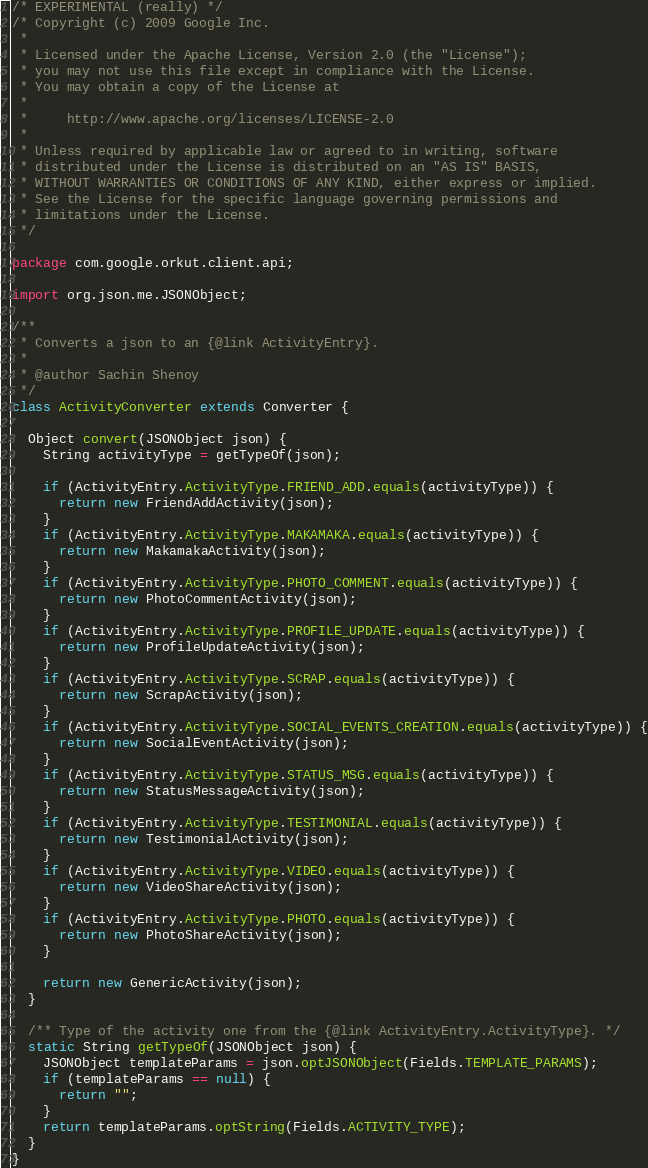Convert code to text. <code><loc_0><loc_0><loc_500><loc_500><_Java_>/* EXPERIMENTAL (really) */
/* Copyright (c) 2009 Google Inc.
 *
 * Licensed under the Apache License, Version 2.0 (the "License");
 * you may not use this file except in compliance with the License.
 * You may obtain a copy of the License at
 *
 *     http://www.apache.org/licenses/LICENSE-2.0
 *
 * Unless required by applicable law or agreed to in writing, software
 * distributed under the License is distributed on an "AS IS" BASIS,
 * WITHOUT WARRANTIES OR CONDITIONS OF ANY KIND, either express or implied.
 * See the License for the specific language governing permissions and
 * limitations under the License.
 */

package com.google.orkut.client.api;

import org.json.me.JSONObject;

/**
 * Converts a json to an {@link ActivityEntry}.
 *
 * @author Sachin Shenoy
 */
class ActivityConverter extends Converter {

  Object convert(JSONObject json) {
    String activityType = getTypeOf(json);

    if (ActivityEntry.ActivityType.FRIEND_ADD.equals(activityType)) {
      return new FriendAddActivity(json);
    }
    if (ActivityEntry.ActivityType.MAKAMAKA.equals(activityType)) {
      return new MakamakaActivity(json);
    }
    if (ActivityEntry.ActivityType.PHOTO_COMMENT.equals(activityType)) {
      return new PhotoCommentActivity(json);
    }
    if (ActivityEntry.ActivityType.PROFILE_UPDATE.equals(activityType)) {
      return new ProfileUpdateActivity(json);
    }
    if (ActivityEntry.ActivityType.SCRAP.equals(activityType)) {
      return new ScrapActivity(json);
    }
    if (ActivityEntry.ActivityType.SOCIAL_EVENTS_CREATION.equals(activityType)) {
      return new SocialEventActivity(json);
    }
    if (ActivityEntry.ActivityType.STATUS_MSG.equals(activityType)) {
      return new StatusMessageActivity(json);
    }
    if (ActivityEntry.ActivityType.TESTIMONIAL.equals(activityType)) {
      return new TestimonialActivity(json);
    }
    if (ActivityEntry.ActivityType.VIDEO.equals(activityType)) {
      return new VideoShareActivity(json);
    }
    if (ActivityEntry.ActivityType.PHOTO.equals(activityType)) {
      return new PhotoShareActivity(json);
    }

    return new GenericActivity(json);
  }

  /** Type of the activity one from the {@link ActivityEntry.ActivityType}. */
  static String getTypeOf(JSONObject json) {
    JSONObject templateParams = json.optJSONObject(Fields.TEMPLATE_PARAMS);
    if (templateParams == null) {
      return "";
    }
    return templateParams.optString(Fields.ACTIVITY_TYPE);
  }
}
</code> 